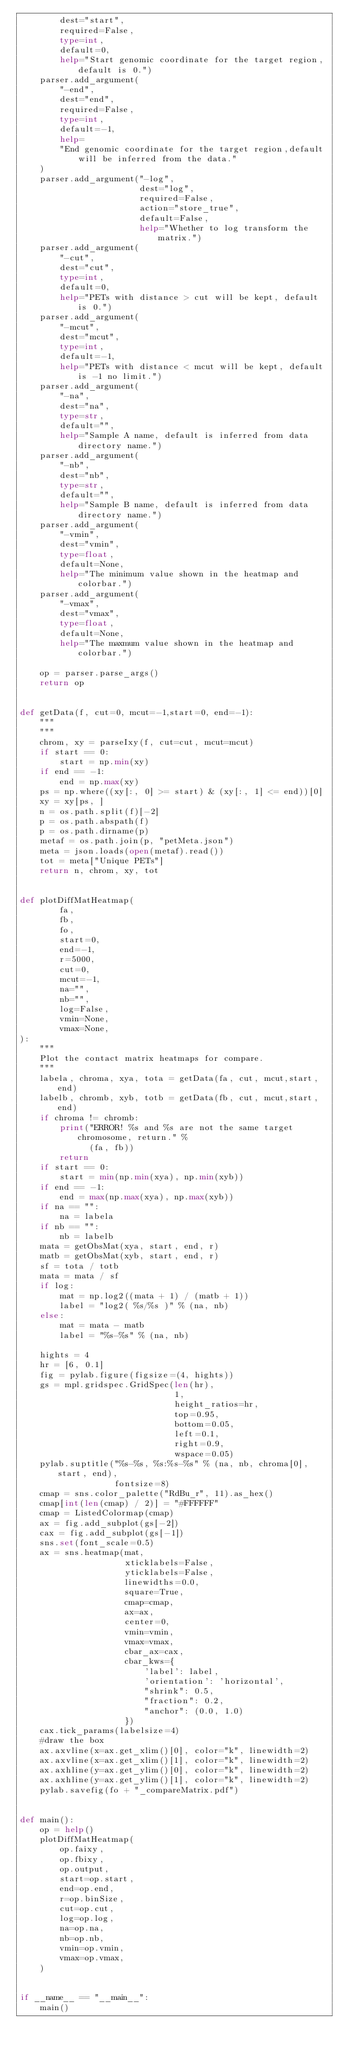Convert code to text. <code><loc_0><loc_0><loc_500><loc_500><_Python_>        dest="start",
        required=False,
        type=int,
        default=0,
        help="Start genomic coordinate for the target region,default is 0.")
    parser.add_argument(
        "-end",
        dest="end",
        required=False,
        type=int,
        default=-1,
        help=
        "End genomic coordinate for the target region,default will be inferred from the data."
    )
    parser.add_argument("-log",
                        dest="log",
                        required=False,
                        action="store_true",
                        default=False,
                        help="Whether to log transform the matrix.")
    parser.add_argument(
        "-cut",
        dest="cut",
        type=int,
        default=0,
        help="PETs with distance > cut will be kept, default is 0.")
    parser.add_argument(
        "-mcut",
        dest="mcut",
        type=int,
        default=-1,
        help="PETs with distance < mcut will be kept, default is -1 no limit.")
    parser.add_argument(
        "-na",
        dest="na",
        type=str,
        default="",
        help="Sample A name, default is inferred from data directory name.")
    parser.add_argument(
        "-nb",
        dest="nb",
        type=str,
        default="",
        help="Sample B name, default is inferred from data directory name.")
    parser.add_argument(
        "-vmin",
        dest="vmin",
        type=float,
        default=None,
        help="The minimum value shown in the heatmap and colorbar.")
    parser.add_argument(
        "-vmax",
        dest="vmax",
        type=float,
        default=None,
        help="The maxmum value shown in the heatmap and colorbar.")

    op = parser.parse_args()
    return op


def getData(f, cut=0, mcut=-1,start=0, end=-1):
    """
    """
    chrom, xy = parseIxy(f, cut=cut, mcut=mcut)
    if start == 0:
        start = np.min(xy)
    if end == -1:
        end = np.max(xy)
    ps = np.where((xy[:, 0] >= start) & (xy[:, 1] <= end))[0]
    xy = xy[ps, ]
    n = os.path.split(f)[-2]
    p = os.path.abspath(f)
    p = os.path.dirname(p)
    metaf = os.path.join(p, "petMeta.json")
    meta = json.loads(open(metaf).read())
    tot = meta["Unique PETs"]
    return n, chrom, xy, tot


def plotDiffMatHeatmap(
        fa,
        fb,
        fo,
        start=0,
        end=-1,
        r=5000,
        cut=0,
        mcut=-1,
        na="",
        nb="",
        log=False,
        vmin=None,
        vmax=None,
):
    """
    Plot the contact matrix heatmaps for compare.
    """
    labela, chroma, xya, tota = getData(fa, cut, mcut,start,end)
    labelb, chromb, xyb, totb = getData(fb, cut, mcut,start,end)
    if chroma != chromb:
        print("ERROR! %s and %s are not the same target chromosome, return." %
              (fa, fb))
        return
    if start == 0:
        start = min(np.min(xya), np.min(xyb))
    if end == -1:
        end = max(np.max(xya), np.max(xyb))
    if na == "":
        na = labela
    if nb == "":
        nb = labelb
    mata = getObsMat(xya, start, end, r)
    matb = getObsMat(xyb, start, end, r)
    sf = tota / totb
    mata = mata / sf
    if log:
        mat = np.log2((mata + 1) / (matb + 1))
        label = "log2( %s/%s )" % (na, nb)
    else:
        mat = mata - matb
        label = "%s-%s" % (na, nb)

    hights = 4
    hr = [6, 0.1]
    fig = pylab.figure(figsize=(4, hights))
    gs = mpl.gridspec.GridSpec(len(hr),
                               1,
                               height_ratios=hr,
                               top=0.95,
                               bottom=0.05,
                               left=0.1,
                               right=0.9,
                               wspace=0.05)
    pylab.suptitle("%s-%s, %s:%s-%s" % (na, nb, chroma[0], start, end),
                   fontsize=8)
    cmap = sns.color_palette("RdBu_r", 11).as_hex()
    cmap[int(len(cmap) / 2)] = "#FFFFFF"
    cmap = ListedColormap(cmap)
    ax = fig.add_subplot(gs[-2])
    cax = fig.add_subplot(gs[-1])
    sns.set(font_scale=0.5)
    ax = sns.heatmap(mat,
                     xticklabels=False,
                     yticklabels=False,
                     linewidths=0.0,
                     square=True,
                     cmap=cmap,
                     ax=ax,
                     center=0,
                     vmin=vmin,
                     vmax=vmax,
                     cbar_ax=cax,
                     cbar_kws={
                         'label': label,
                         'orientation': 'horizontal',
                         "shrink": 0.5,
                         "fraction": 0.2,
                         "anchor": (0.0, 1.0)
                     })
    cax.tick_params(labelsize=4)
    #draw the box
    ax.axvline(x=ax.get_xlim()[0], color="k", linewidth=2)
    ax.axvline(x=ax.get_xlim()[1], color="k", linewidth=2)
    ax.axhline(y=ax.get_ylim()[0], color="k", linewidth=2)
    ax.axhline(y=ax.get_ylim()[1], color="k", linewidth=2)
    pylab.savefig(fo + "_compareMatrix.pdf")


def main():
    op = help()
    plotDiffMatHeatmap(
        op.faixy,
        op.fbixy,
        op.output,
        start=op.start,
        end=op.end,
        r=op.binSize,
        cut=op.cut,
        log=op.log,
        na=op.na,
        nb=op.nb,
        vmin=op.vmin,
        vmax=op.vmax,
    )


if __name__ == "__main__":
    main()
</code> 